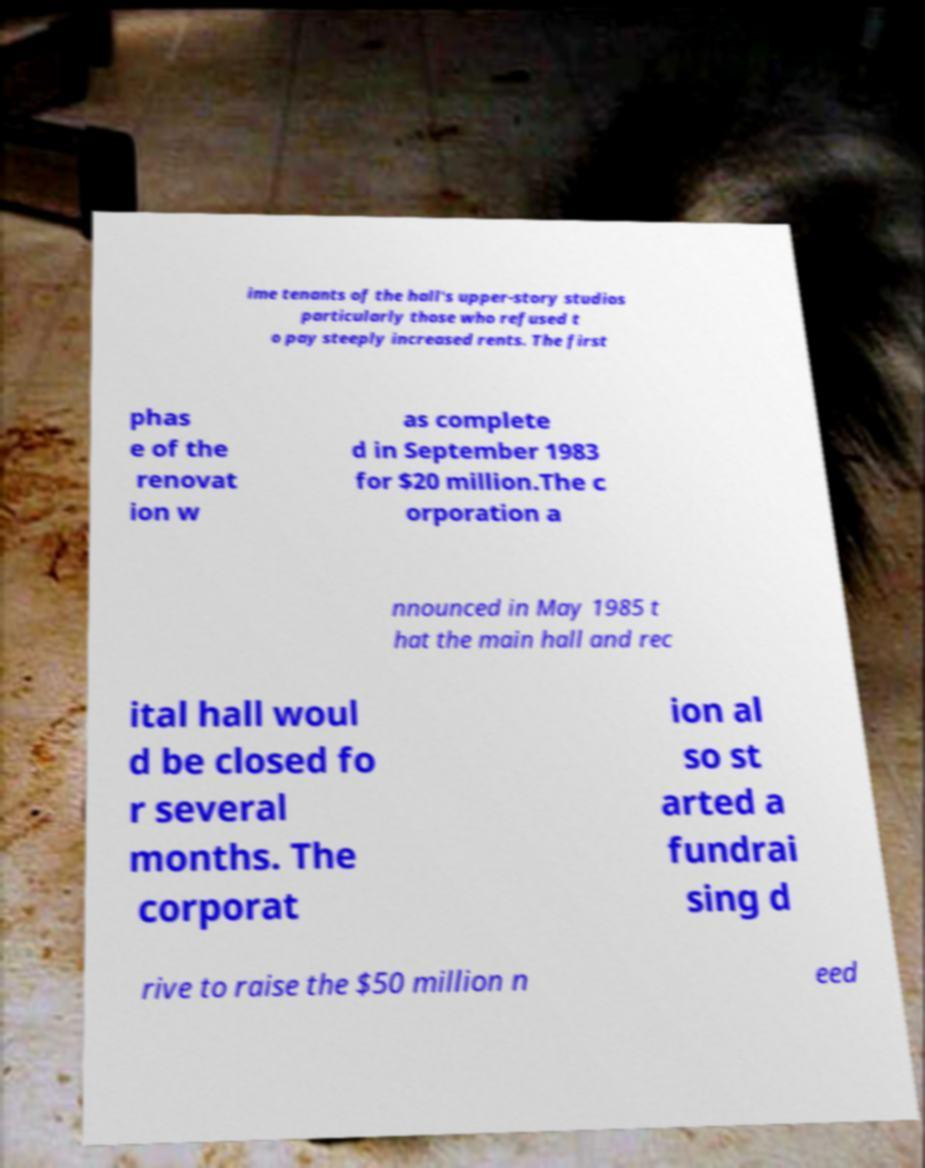For documentation purposes, I need the text within this image transcribed. Could you provide that? ime tenants of the hall's upper-story studios particularly those who refused t o pay steeply increased rents. The first phas e of the renovat ion w as complete d in September 1983 for $20 million.The c orporation a nnounced in May 1985 t hat the main hall and rec ital hall woul d be closed fo r several months. The corporat ion al so st arted a fundrai sing d rive to raise the $50 million n eed 